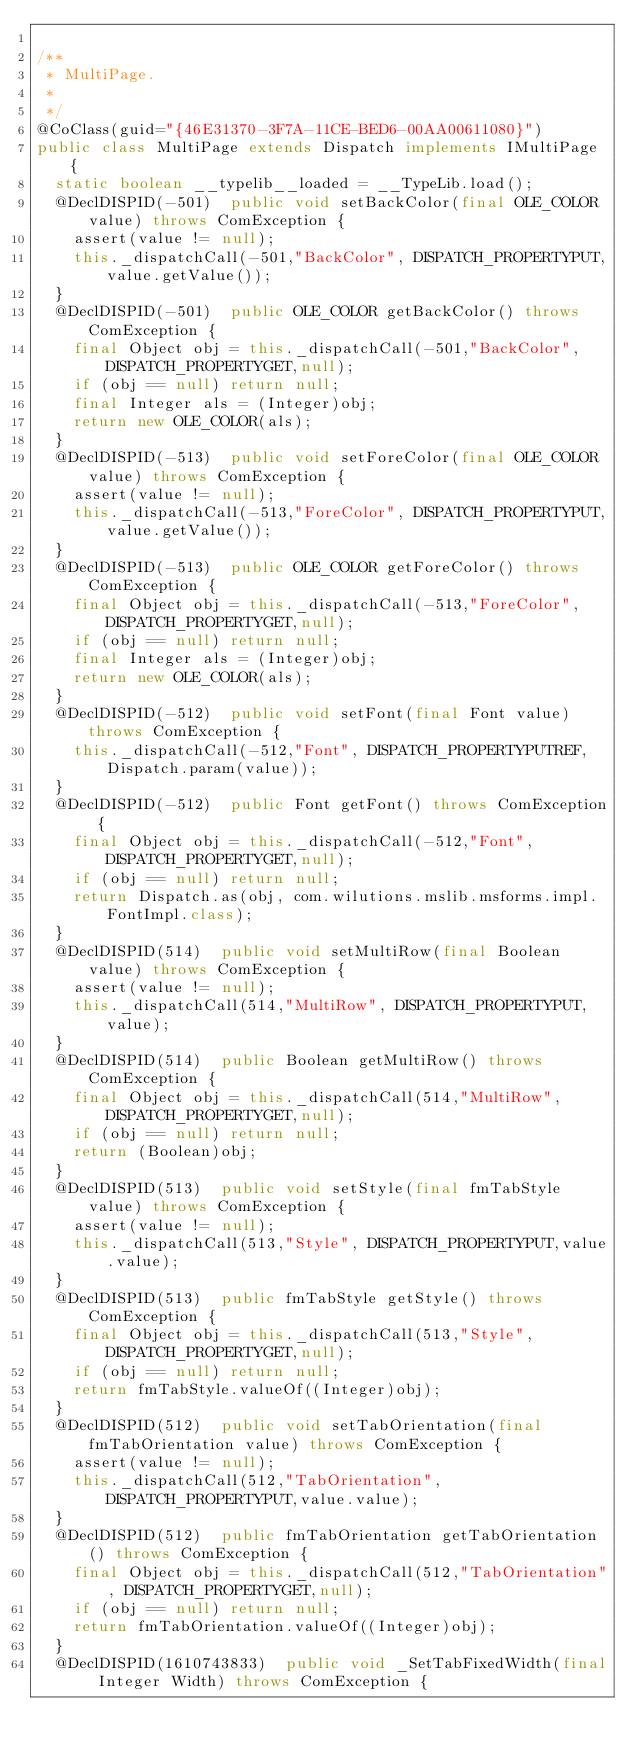<code> <loc_0><loc_0><loc_500><loc_500><_Java_>
/**
 * MultiPage.
 * 
 */
@CoClass(guid="{46E31370-3F7A-11CE-BED6-00AA00611080}")
public class MultiPage extends Dispatch implements IMultiPage {
  static boolean __typelib__loaded = __TypeLib.load();
  @DeclDISPID(-501)  public void setBackColor(final OLE_COLOR value) throws ComException {
    assert(value != null);
    this._dispatchCall(-501,"BackColor", DISPATCH_PROPERTYPUT,value.getValue());
  }
  @DeclDISPID(-501)  public OLE_COLOR getBackColor() throws ComException {
    final Object obj = this._dispatchCall(-501,"BackColor", DISPATCH_PROPERTYGET,null);
    if (obj == null) return null;
    final Integer als = (Integer)obj;
    return new OLE_COLOR(als);
  }
  @DeclDISPID(-513)  public void setForeColor(final OLE_COLOR value) throws ComException {
    assert(value != null);
    this._dispatchCall(-513,"ForeColor", DISPATCH_PROPERTYPUT,value.getValue());
  }
  @DeclDISPID(-513)  public OLE_COLOR getForeColor() throws ComException {
    final Object obj = this._dispatchCall(-513,"ForeColor", DISPATCH_PROPERTYGET,null);
    if (obj == null) return null;
    final Integer als = (Integer)obj;
    return new OLE_COLOR(als);
  }
  @DeclDISPID(-512)  public void setFont(final Font value) throws ComException {
    this._dispatchCall(-512,"Font", DISPATCH_PROPERTYPUTREF,Dispatch.param(value));
  }
  @DeclDISPID(-512)  public Font getFont() throws ComException {
    final Object obj = this._dispatchCall(-512,"Font", DISPATCH_PROPERTYGET,null);
    if (obj == null) return null;
    return Dispatch.as(obj, com.wilutions.mslib.msforms.impl.FontImpl.class);
  }
  @DeclDISPID(514)  public void setMultiRow(final Boolean value) throws ComException {
    assert(value != null);
    this._dispatchCall(514,"MultiRow", DISPATCH_PROPERTYPUT,value);
  }
  @DeclDISPID(514)  public Boolean getMultiRow() throws ComException {
    final Object obj = this._dispatchCall(514,"MultiRow", DISPATCH_PROPERTYGET,null);
    if (obj == null) return null;
    return (Boolean)obj;
  }
  @DeclDISPID(513)  public void setStyle(final fmTabStyle value) throws ComException {
    assert(value != null);
    this._dispatchCall(513,"Style", DISPATCH_PROPERTYPUT,value.value);
  }
  @DeclDISPID(513)  public fmTabStyle getStyle() throws ComException {
    final Object obj = this._dispatchCall(513,"Style", DISPATCH_PROPERTYGET,null);
    if (obj == null) return null;
    return fmTabStyle.valueOf((Integer)obj);
  }
  @DeclDISPID(512)  public void setTabOrientation(final fmTabOrientation value) throws ComException {
    assert(value != null);
    this._dispatchCall(512,"TabOrientation", DISPATCH_PROPERTYPUT,value.value);
  }
  @DeclDISPID(512)  public fmTabOrientation getTabOrientation() throws ComException {
    final Object obj = this._dispatchCall(512,"TabOrientation", DISPATCH_PROPERTYGET,null);
    if (obj == null) return null;
    return fmTabOrientation.valueOf((Integer)obj);
  }
  @DeclDISPID(1610743833)  public void _SetTabFixedWidth(final Integer Width) throws ComException {</code> 